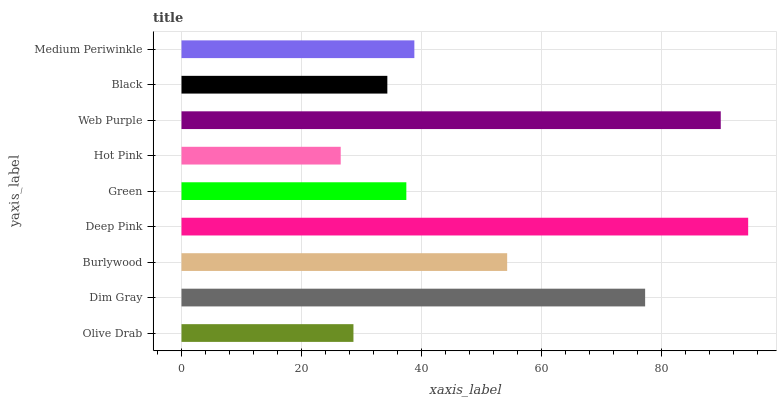Is Hot Pink the minimum?
Answer yes or no. Yes. Is Deep Pink the maximum?
Answer yes or no. Yes. Is Dim Gray the minimum?
Answer yes or no. No. Is Dim Gray the maximum?
Answer yes or no. No. Is Dim Gray greater than Olive Drab?
Answer yes or no. Yes. Is Olive Drab less than Dim Gray?
Answer yes or no. Yes. Is Olive Drab greater than Dim Gray?
Answer yes or no. No. Is Dim Gray less than Olive Drab?
Answer yes or no. No. Is Medium Periwinkle the high median?
Answer yes or no. Yes. Is Medium Periwinkle the low median?
Answer yes or no. Yes. Is Burlywood the high median?
Answer yes or no. No. Is Green the low median?
Answer yes or no. No. 